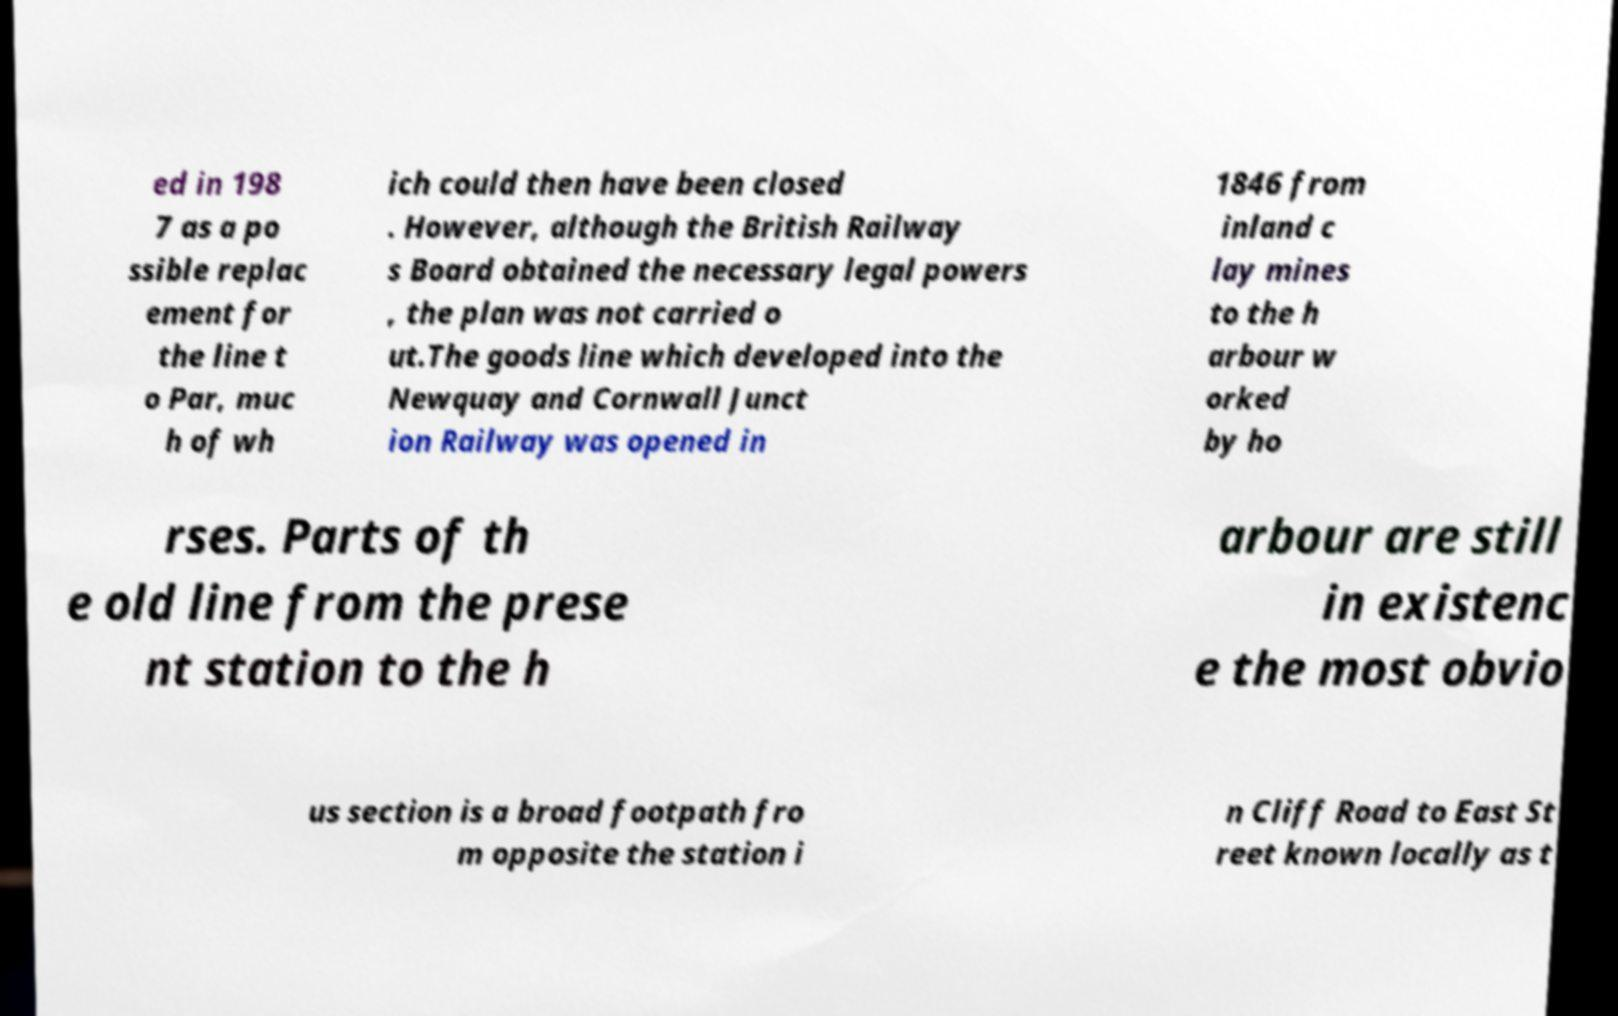Please identify and transcribe the text found in this image. ed in 198 7 as a po ssible replac ement for the line t o Par, muc h of wh ich could then have been closed . However, although the British Railway s Board obtained the necessary legal powers , the plan was not carried o ut.The goods line which developed into the Newquay and Cornwall Junct ion Railway was opened in 1846 from inland c lay mines to the h arbour w orked by ho rses. Parts of th e old line from the prese nt station to the h arbour are still in existenc e the most obvio us section is a broad footpath fro m opposite the station i n Cliff Road to East St reet known locally as t 